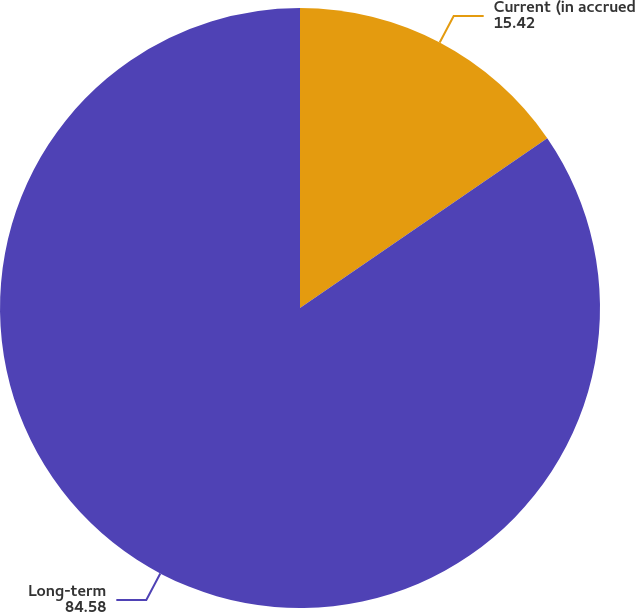Convert chart to OTSL. <chart><loc_0><loc_0><loc_500><loc_500><pie_chart><fcel>Current (in accrued<fcel>Long-term<nl><fcel>15.42%<fcel>84.58%<nl></chart> 